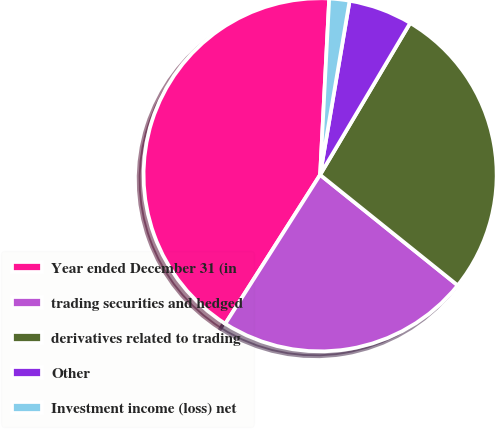Convert chart to OTSL. <chart><loc_0><loc_0><loc_500><loc_500><pie_chart><fcel>Year ended December 31 (in<fcel>trading securities and hedged<fcel>derivatives related to trading<fcel>Other<fcel>Investment income (loss) net<nl><fcel>41.8%<fcel>23.25%<fcel>27.25%<fcel>5.85%<fcel>1.85%<nl></chart> 